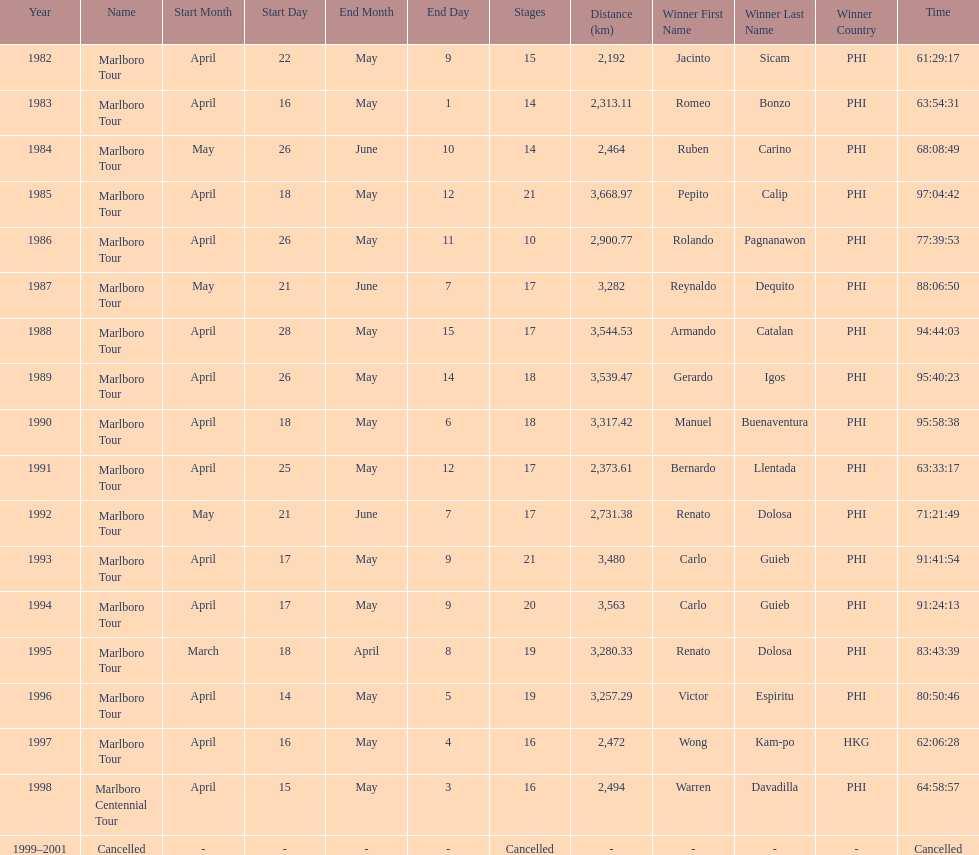What was the total number of winners before the tour was canceled? 17. Can you parse all the data within this table? {'header': ['Year', 'Name', 'Start Month', 'Start Day', 'End Month', 'End Day', 'Stages', 'Distance (km)', 'Winner First Name', 'Winner Last Name', 'Winner Country', 'Time'], 'rows': [['1982', 'Marlboro Tour', 'April', '22', 'May', '9', '15', '2,192', 'Jacinto', 'Sicam', 'PHI', '61:29:17'], ['1983', 'Marlboro Tour', 'April', '16', 'May', '1', '14', '2,313.11', 'Romeo', 'Bonzo', 'PHI', '63:54:31'], ['1984', 'Marlboro Tour', 'May', '26', 'June', '10', '14', '2,464', 'Ruben', 'Carino', 'PHI', '68:08:49'], ['1985', 'Marlboro Tour', 'April', '18', 'May', '12', '21', '3,668.97', 'Pepito', 'Calip', 'PHI', '97:04:42'], ['1986', 'Marlboro Tour', 'April', '26', 'May', '11', '10', '2,900.77', 'Rolando', 'Pagnanawon', 'PHI', '77:39:53'], ['1987', 'Marlboro Tour', 'May', '21', 'June', '7', '17', '3,282', 'Reynaldo', 'Dequito', 'PHI', '88:06:50'], ['1988', 'Marlboro Tour', 'April', '28', 'May', '15', '17', '3,544.53', 'Armando', 'Catalan', 'PHI', '94:44:03'], ['1989', 'Marlboro Tour', 'April', '26', 'May', '14', '18', '3,539.47', 'Gerardo', 'Igos', 'PHI', '95:40:23'], ['1990', 'Marlboro Tour', 'April', '18', 'May', '6', '18', '3,317.42', 'Manuel', 'Buenaventura', 'PHI', '95:58:38'], ['1991', 'Marlboro Tour', 'April', '25', 'May', '12', '17', '2,373.61', 'Bernardo', 'Llentada', 'PHI', '63:33:17'], ['1992', 'Marlboro Tour', 'May', '21', 'June', '7', '17', '2,731.38', 'Renato', 'Dolosa', 'PHI', '71:21:49'], ['1993', 'Marlboro Tour', 'April', '17', 'May', '9', '21', '3,480', 'Carlo', 'Guieb', 'PHI', '91:41:54'], ['1994', 'Marlboro Tour', 'April', '17', 'May', '9', '20', '3,563', 'Carlo', 'Guieb', 'PHI', '91:24:13'], ['1995', 'Marlboro Tour', 'March', '18', 'April', '8', '19', '3,280.33', 'Renato', 'Dolosa', 'PHI', '83:43:39'], ['1996', 'Marlboro Tour', 'April', '14', 'May', '5', '19', '3,257.29', 'Victor', 'Espiritu', 'PHI', '80:50:46'], ['1997', 'Marlboro Tour', 'April', '16', 'May', '4', '16', '2,472', 'Wong', 'Kam-po', 'HKG', '62:06:28'], ['1998', 'Marlboro Centennial Tour', 'April', '15', 'May', '3', '16', '2,494', 'Warren', 'Davadilla', 'PHI', '64:58:57'], ['1999–2001', 'Cancelled', '-', '-', '-', '-', 'Cancelled', '-', '-', '-', '-', 'Cancelled']]} 